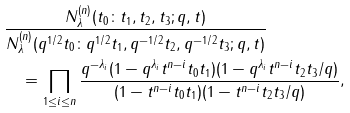<formula> <loc_0><loc_0><loc_500><loc_500>& \frac { N ^ { ( n ) } _ { \lambda } ( t _ { 0 } { \colon } t _ { 1 } , t _ { 2 } , t _ { 3 } ; q , t ) } { N ^ { ( n ) } _ { \lambda } ( q ^ { 1 / 2 } t _ { 0 } { \colon } q ^ { 1 / 2 } t _ { 1 } , q ^ { - 1 / 2 } t _ { 2 } , q ^ { - 1 / 2 } t _ { 3 } ; q , t ) } \\ & \quad = \prod _ { 1 \leq i \leq n } \frac { q ^ { - \lambda _ { i } } ( 1 - q ^ { \lambda _ { i } } t ^ { n - i } t _ { 0 } t _ { 1 } ) ( 1 - q ^ { \lambda _ { i } } t ^ { n - i } t _ { 2 } t _ { 3 } / q ) } { ( 1 - t ^ { n - i } t _ { 0 } t _ { 1 } ) ( 1 - t ^ { n - i } t _ { 2 } t _ { 3 } / q ) } ,</formula> 